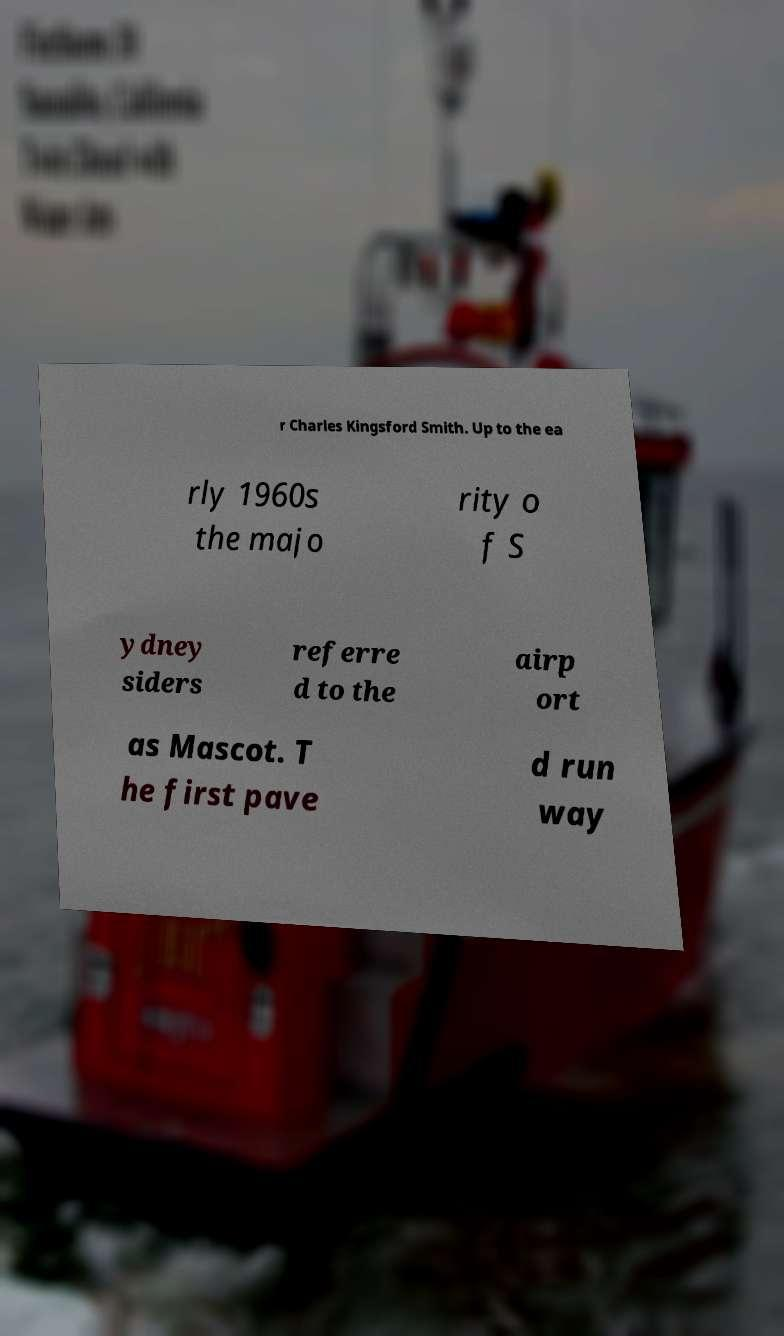Please identify and transcribe the text found in this image. r Charles Kingsford Smith. Up to the ea rly 1960s the majo rity o f S ydney siders referre d to the airp ort as Mascot. T he first pave d run way 